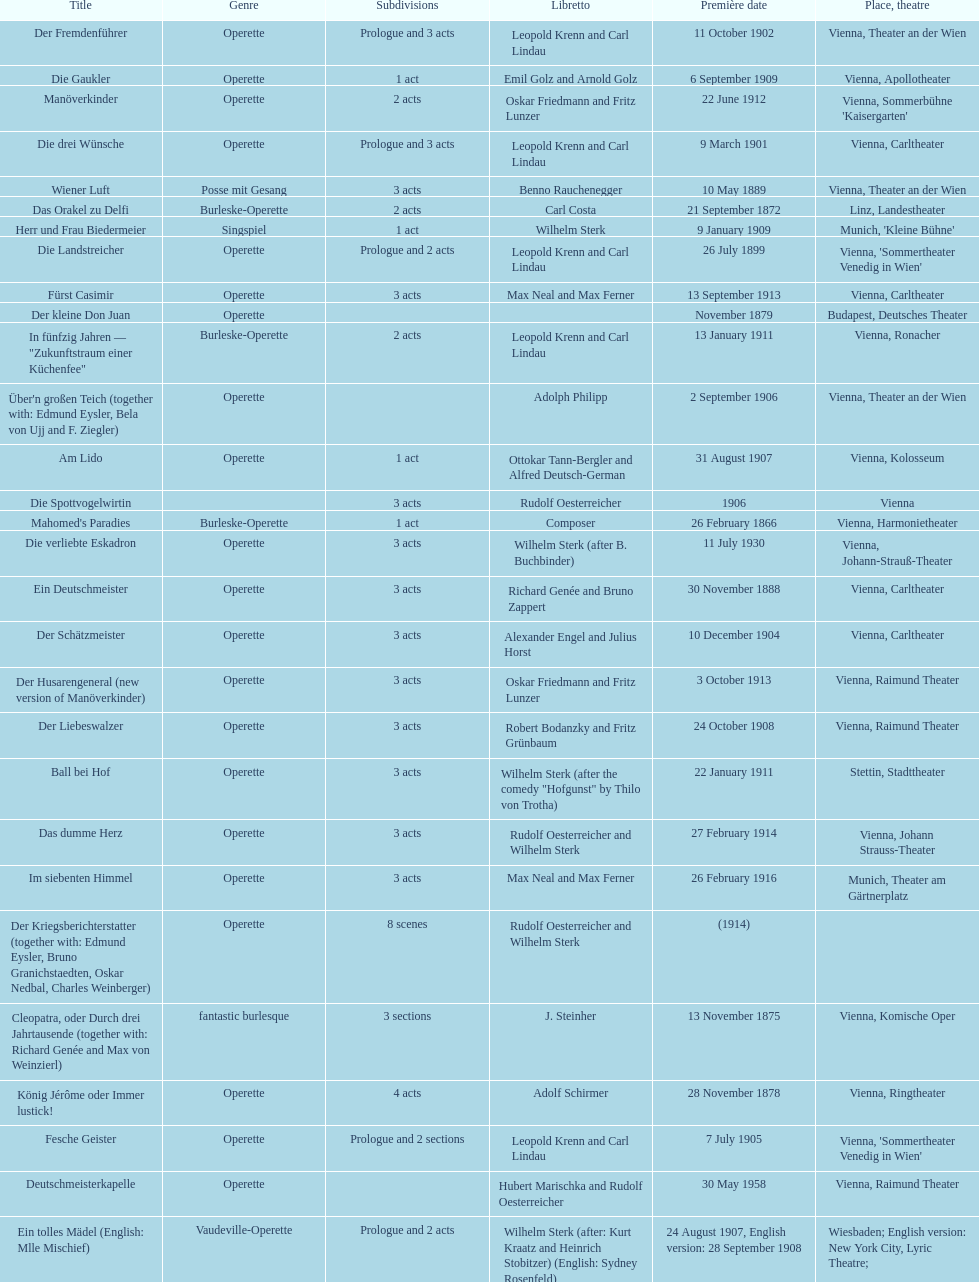Help me parse the entirety of this table. {'header': ['Title', 'Genre', 'Sub\xaddivisions', 'Libretto', 'Première date', 'Place, theatre'], 'rows': [['Der Fremdenführer', 'Operette', 'Prologue and 3 acts', 'Leopold Krenn and Carl Lindau', '11 October 1902', 'Vienna, Theater an der Wien'], ['Die Gaukler', 'Operette', '1 act', 'Emil Golz and Arnold Golz', '6 September 1909', 'Vienna, Apollotheater'], ['Manöverkinder', 'Operette', '2 acts', 'Oskar Friedmann and Fritz Lunzer', '22 June 1912', "Vienna, Sommerbühne 'Kaisergarten'"], ['Die drei Wünsche', 'Operette', 'Prologue and 3 acts', 'Leopold Krenn and Carl Lindau', '9 March 1901', 'Vienna, Carltheater'], ['Wiener Luft', 'Posse mit Gesang', '3 acts', 'Benno Rauchenegger', '10 May 1889', 'Vienna, Theater an der Wien'], ['Das Orakel zu Delfi', 'Burleske-Operette', '2 acts', 'Carl Costa', '21 September 1872', 'Linz, Landestheater'], ['Herr und Frau Biedermeier', 'Singspiel', '1 act', 'Wilhelm Sterk', '9 January 1909', "Munich, 'Kleine Bühne'"], ['Die Landstreicher', 'Operette', 'Prologue and 2 acts', 'Leopold Krenn and Carl Lindau', '26 July 1899', "Vienna, 'Sommertheater Venedig in Wien'"], ['Fürst Casimir', 'Operette', '3 acts', 'Max Neal and Max Ferner', '13 September 1913', 'Vienna, Carltheater'], ['Der kleine Don Juan', 'Operette', '', '', 'November 1879', 'Budapest, Deutsches Theater'], ['In fünfzig Jahren — "Zukunftstraum einer Küchenfee"', 'Burleske-Operette', '2 acts', 'Leopold Krenn and Carl Lindau', '13 January 1911', 'Vienna, Ronacher'], ["Über'n großen Teich (together with: Edmund Eysler, Bela von Ujj and F. Ziegler)", 'Operette', '', 'Adolph Philipp', '2 September 1906', 'Vienna, Theater an der Wien'], ['Am Lido', 'Operette', '1 act', 'Ottokar Tann-Bergler and Alfred Deutsch-German', '31 August 1907', 'Vienna, Kolosseum'], ['Die Spottvogelwirtin', '', '3 acts', 'Rudolf Oesterreicher', '1906', 'Vienna'], ["Mahomed's Paradies", 'Burleske-Operette', '1 act', 'Composer', '26 February 1866', 'Vienna, Harmonietheater'], ['Die verliebte Eskadron', 'Operette', '3 acts', 'Wilhelm Sterk (after B. Buchbinder)', '11 July 1930', 'Vienna, Johann-Strauß-Theater'], ['Ein Deutschmeister', 'Operette', '3 acts', 'Richard Genée and Bruno Zappert', '30 November 1888', 'Vienna, Carltheater'], ['Der Schätzmeister', 'Operette', '3 acts', 'Alexander Engel and Julius Horst', '10 December 1904', 'Vienna, Carltheater'], ['Der Husarengeneral (new version of Manöverkinder)', 'Operette', '3 acts', 'Oskar Friedmann and Fritz Lunzer', '3 October 1913', 'Vienna, Raimund Theater'], ['Der Liebeswalzer', 'Operette', '3 acts', 'Robert Bodanzky and Fritz Grünbaum', '24 October 1908', 'Vienna, Raimund Theater'], ['Ball bei Hof', 'Operette', '3 acts', 'Wilhelm Sterk (after the comedy "Hofgunst" by Thilo von Trotha)', '22 January 1911', 'Stettin, Stadttheater'], ['Das dumme Herz', 'Operette', '3 acts', 'Rudolf Oesterreicher and Wilhelm Sterk', '27 February 1914', 'Vienna, Johann Strauss-Theater'], ['Im siebenten Himmel', 'Operette', '3 acts', 'Max Neal and Max Ferner', '26 February 1916', 'Munich, Theater am Gärtnerplatz'], ['Der Kriegsberichterstatter (together with: Edmund Eysler, Bruno Granichstaedten, Oskar Nedbal, Charles Weinberger)', 'Operette', '8 scenes', 'Rudolf Oesterreicher and Wilhelm Sterk', '(1914)', ''], ['Cleopatra, oder Durch drei Jahrtausende (together with: Richard Genée and Max von Weinzierl)', 'fantastic burlesque', '3 sections', 'J. Steinher', '13 November 1875', 'Vienna, Komische Oper'], ['König Jérôme oder Immer lustick!', 'Operette', '4 acts', 'Adolf Schirmer', '28 November 1878', 'Vienna, Ringtheater'], ['Fesche Geister', 'Operette', 'Prologue and 2 sections', 'Leopold Krenn and Carl Lindau', '7 July 1905', "Vienna, 'Sommertheater Venedig in Wien'"], ['Deutschmeisterkapelle', 'Operette', '', 'Hubert Marischka and Rudolf Oesterreicher', '30 May 1958', 'Vienna, Raimund Theater'], ['Ein tolles Mädel (English: Mlle Mischief)', 'Vaudeville-Operette', 'Prologue and 2 acts', 'Wilhelm Sterk (after: Kurt Kraatz and Heinrich Stobitzer) (English: Sydney Rosenfeld)', '24 August 1907, English version: 28 September 1908', 'Wiesbaden; English version: New York City, Lyric Theatre;'], ['Der bleiche Zauberer', 'indianisches Lagerbild', '1 act', 'Isidor Fuchs, based on an Indian story by James Fennimore Cooper', '20 September 1890', 'Vienna, Theater an der Wien'], ['Der schöne Rigo', 'Operette', '2 acts', 'Leopold Krenn and Carl Lindau', '24 May 1898', "Vienna, 'Sommertheater Venedig in Wien'"], ['Wiener Kinder', 'Operette', '3 acts', 'Leopold Krenn and Carl Wolff', '19 January 1881', 'Vienna, Carltheater']]} All the dates are no later than what year? 1958. 